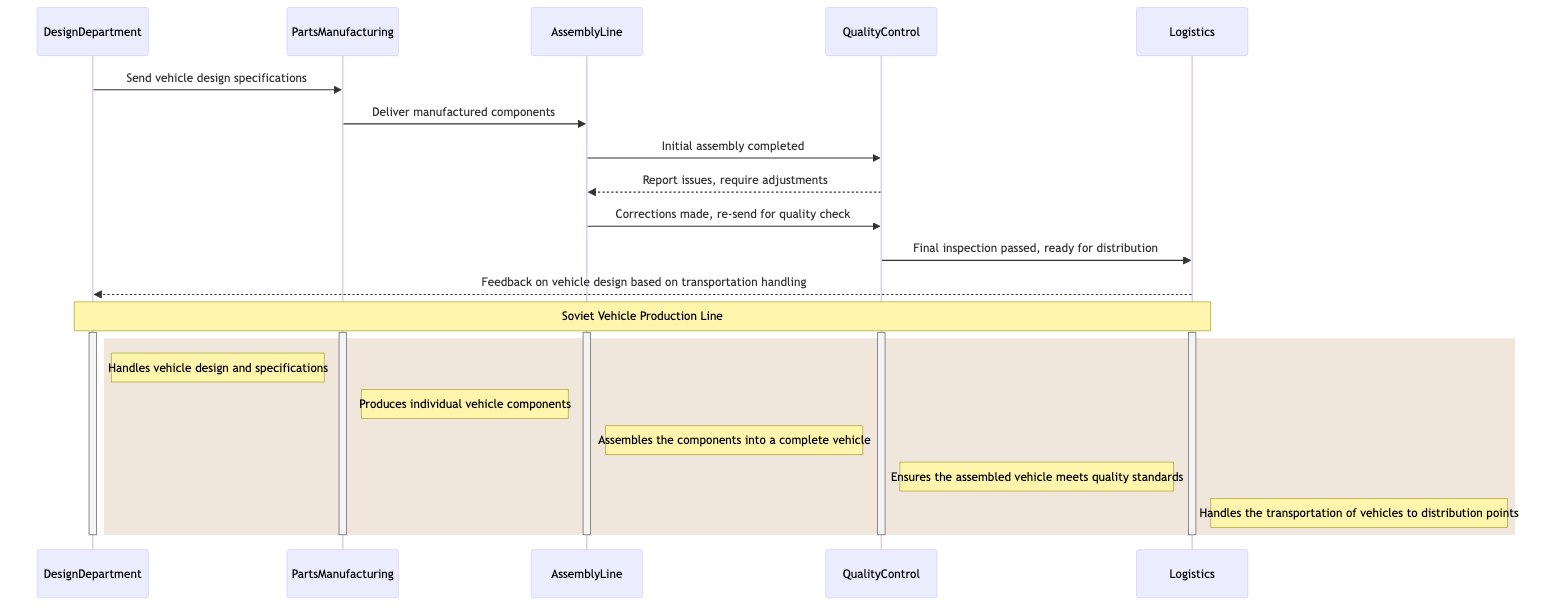What's the first interaction depicted in the diagram? The first interaction is between the DesignDepartment and the PartsManufacturing, where the DesignDepartment sends vehicle design specifications to PartsManufacturing.
Answer: Send vehicle design specifications How many participants are involved in the production line? There are five participants involved in the production line: DesignDepartment, PartsManufacturing, AssemblyLine, QualityControl, and Logistics.
Answer: 5 What does the QualityControl report back to the AssemblyLine? QualityControl reports issues back to AssemblyLine, requiring adjustments after the initial assembly is completed.
Answer: Report issues, require adjustments Which department handles the final inspection before the vehicles are distributed? The QualityControl department is responsible for conducting the final inspection before vehicles can be sent to logistics for distribution.
Answer: QualityControl What is the last interaction in the sequence? The last interaction is between Logistics and DesignDepartment, where Logistics provides feedback about the vehicle design based on its handling during transportation.
Answer: Feedback on vehicle design based on transportation handling Which department is responsible for assembling the manufactured components? The AssemblyLine is responsible for taking the manufactured components and assembling them into a complete vehicle.
Answer: AssemblyLine What happens after initial assembly is completed? After the initial assembly is completed, the AssemblyLine communicates with QualityControl for a quality check.
Answer: Initial assembly completed What is the purpose of the Logistics department in this sequence? The purpose of the Logistics department is to handle the transportation of vehicles to distribution points after they pass the final inspection.
Answer: Handles the transportation of vehicles to distribution points 